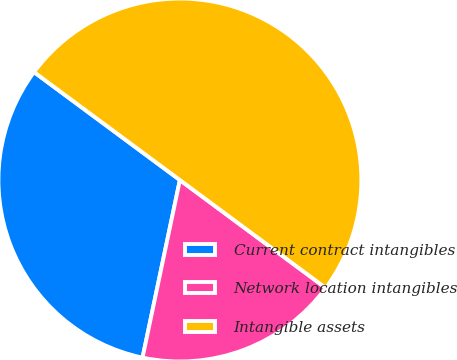Convert chart. <chart><loc_0><loc_0><loc_500><loc_500><pie_chart><fcel>Current contract intangibles<fcel>Network location intangibles<fcel>Intangible assets<nl><fcel>31.84%<fcel>18.16%<fcel>50.0%<nl></chart> 